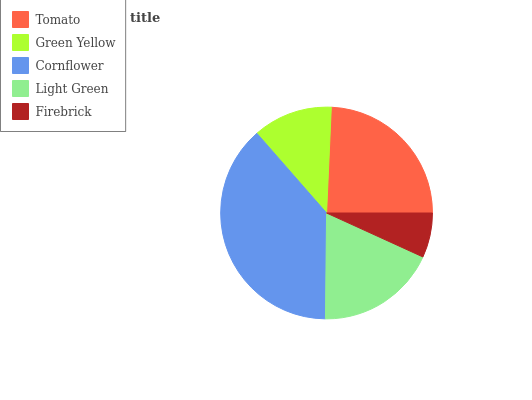Is Firebrick the minimum?
Answer yes or no. Yes. Is Cornflower the maximum?
Answer yes or no. Yes. Is Green Yellow the minimum?
Answer yes or no. No. Is Green Yellow the maximum?
Answer yes or no. No. Is Tomato greater than Green Yellow?
Answer yes or no. Yes. Is Green Yellow less than Tomato?
Answer yes or no. Yes. Is Green Yellow greater than Tomato?
Answer yes or no. No. Is Tomato less than Green Yellow?
Answer yes or no. No. Is Light Green the high median?
Answer yes or no. Yes. Is Light Green the low median?
Answer yes or no. Yes. Is Tomato the high median?
Answer yes or no. No. Is Green Yellow the low median?
Answer yes or no. No. 